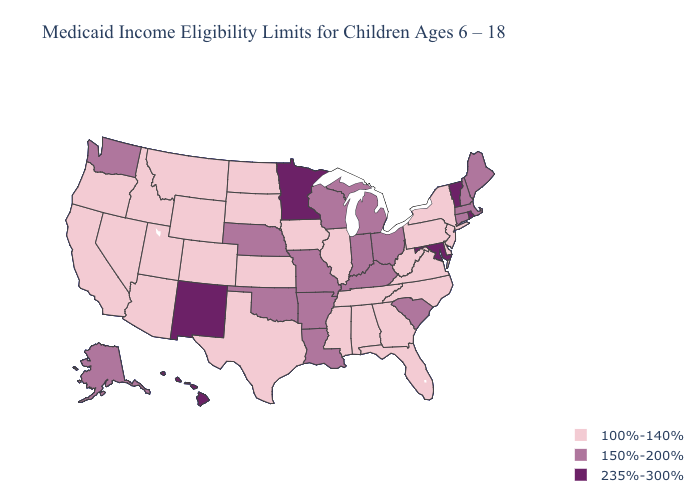What is the lowest value in states that border Iowa?
Concise answer only. 100%-140%. What is the value of Wisconsin?
Answer briefly. 150%-200%. What is the lowest value in the South?
Keep it brief. 100%-140%. Name the states that have a value in the range 100%-140%?
Quick response, please. Alabama, Arizona, California, Colorado, Delaware, Florida, Georgia, Idaho, Illinois, Iowa, Kansas, Mississippi, Montana, Nevada, New Jersey, New York, North Carolina, North Dakota, Oregon, Pennsylvania, South Dakota, Tennessee, Texas, Utah, Virginia, West Virginia, Wyoming. What is the lowest value in states that border Arizona?
Give a very brief answer. 100%-140%. What is the value of Hawaii?
Concise answer only. 235%-300%. Among the states that border New York , which have the highest value?
Short answer required. Vermont. Name the states that have a value in the range 150%-200%?
Quick response, please. Alaska, Arkansas, Connecticut, Indiana, Kentucky, Louisiana, Maine, Massachusetts, Michigan, Missouri, Nebraska, New Hampshire, Ohio, Oklahoma, South Carolina, Washington, Wisconsin. What is the highest value in states that border Oklahoma?
Be succinct. 235%-300%. Does Michigan have the same value as Nebraska?
Give a very brief answer. Yes. What is the value of California?
Give a very brief answer. 100%-140%. Among the states that border North Dakota , does Minnesota have the lowest value?
Short answer required. No. Name the states that have a value in the range 235%-300%?
Write a very short answer. Hawaii, Maryland, Minnesota, New Mexico, Rhode Island, Vermont. Does Oklahoma have a higher value than Louisiana?
Keep it brief. No. What is the value of Ohio?
Quick response, please. 150%-200%. 